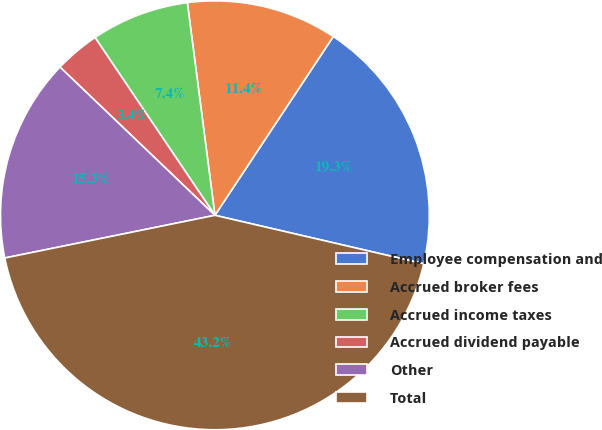<chart> <loc_0><loc_0><loc_500><loc_500><pie_chart><fcel>Employee compensation and<fcel>Accrued broker fees<fcel>Accrued income taxes<fcel>Accrued dividend payable<fcel>Other<fcel>Total<nl><fcel>19.32%<fcel>11.36%<fcel>7.39%<fcel>3.41%<fcel>15.34%<fcel>43.18%<nl></chart> 